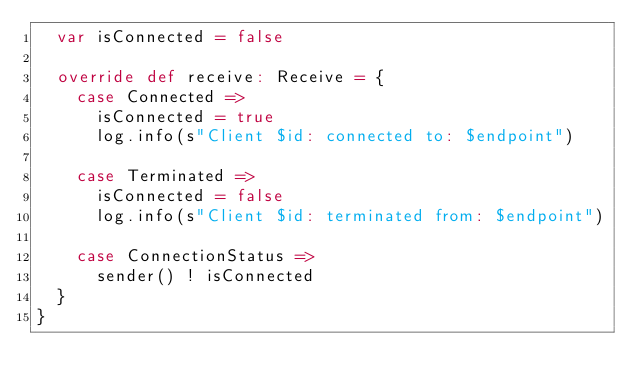<code> <loc_0><loc_0><loc_500><loc_500><_Scala_>  var isConnected = false

  override def receive: Receive = {
    case Connected =>
      isConnected = true
      log.info(s"Client $id: connected to: $endpoint")

    case Terminated =>
      isConnected = false
      log.info(s"Client $id: terminated from: $endpoint")

    case ConnectionStatus =>
      sender() ! isConnected
  }
}
</code> 